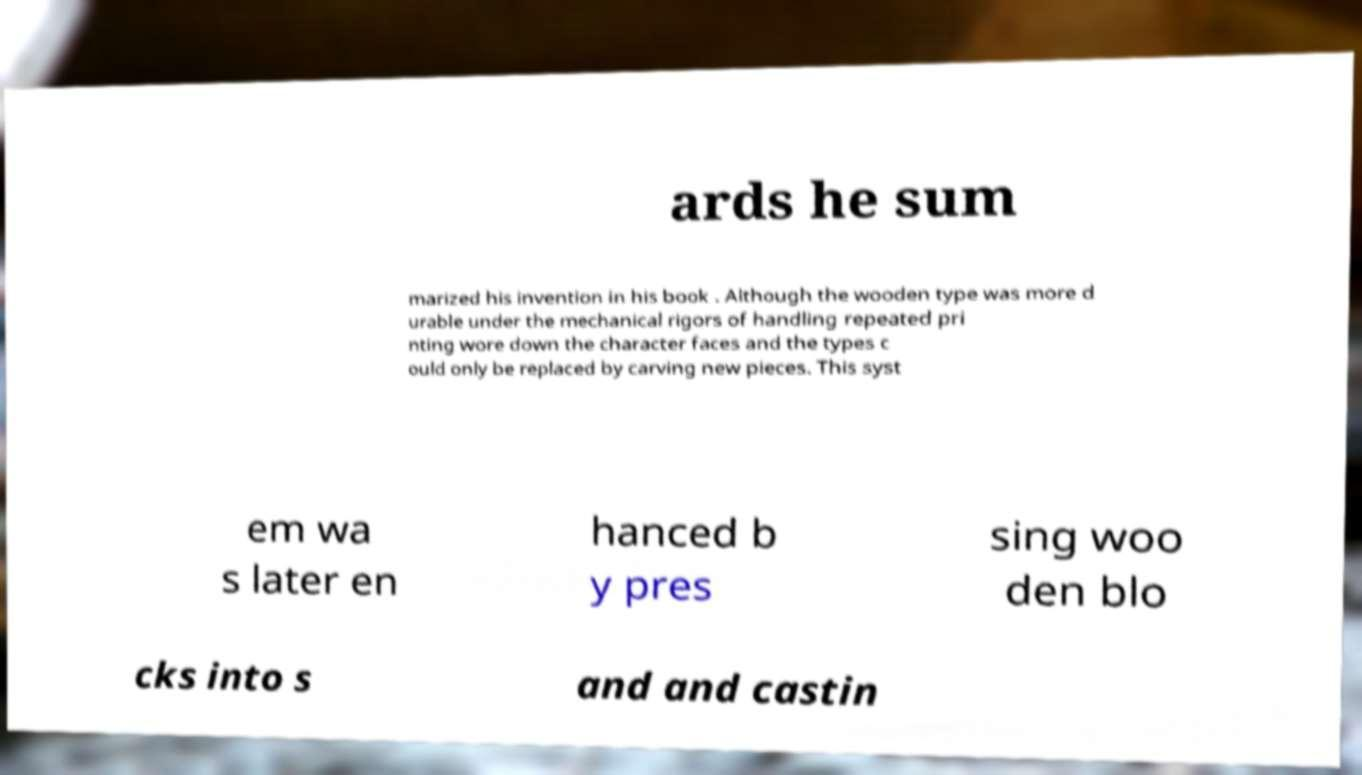For documentation purposes, I need the text within this image transcribed. Could you provide that? ards he sum marized his invention in his book . Although the wooden type was more d urable under the mechanical rigors of handling repeated pri nting wore down the character faces and the types c ould only be replaced by carving new pieces. This syst em wa s later en hanced b y pres sing woo den blo cks into s and and castin 